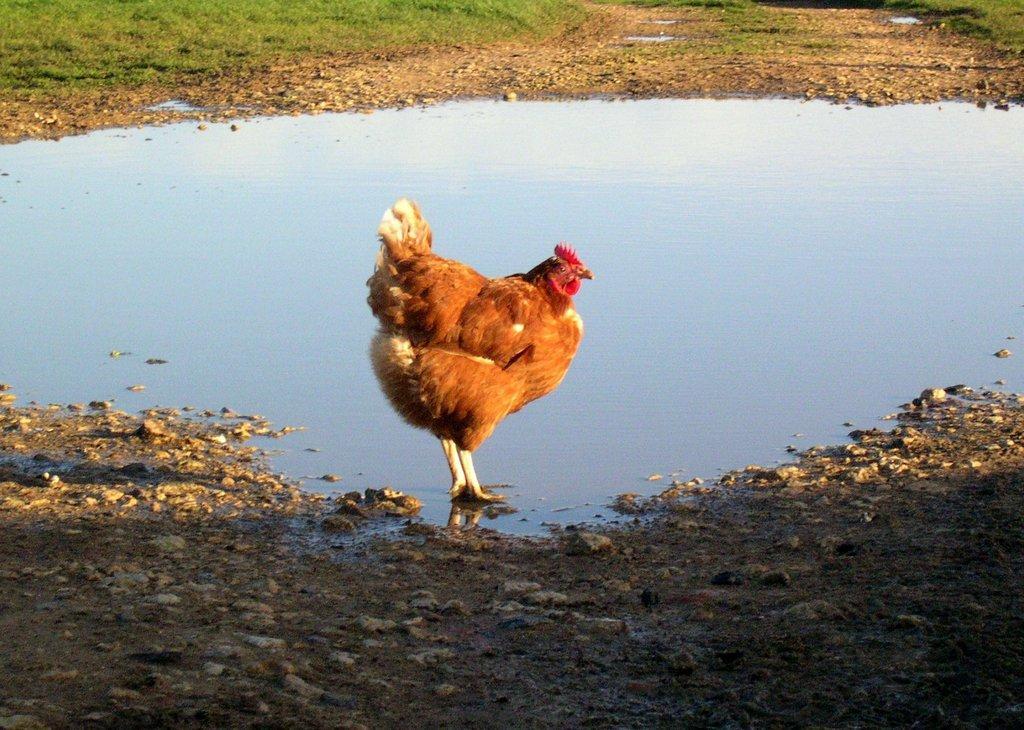Please provide a concise description of this image. In this image I see a hen which is of white, brown and red in color and I see the water. I can also see the ground on which there are stones and I see the green grass. 